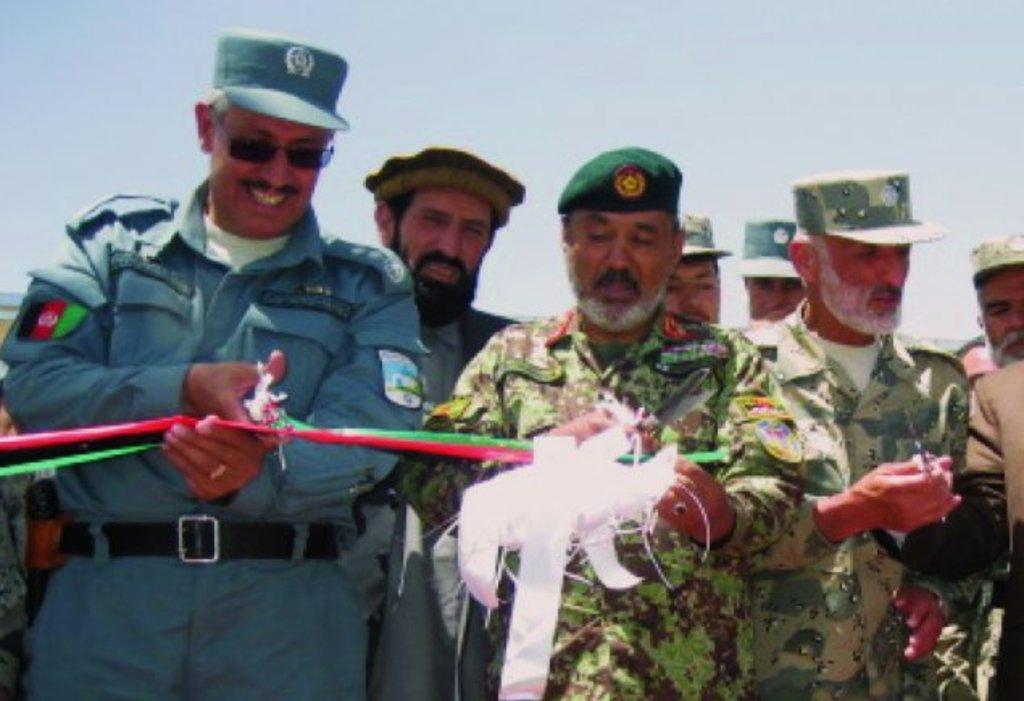Can you describe this image briefly? In the center of the image we can see two people standing and cutting a ribbon. In the background there are people. At the top there is sky. 